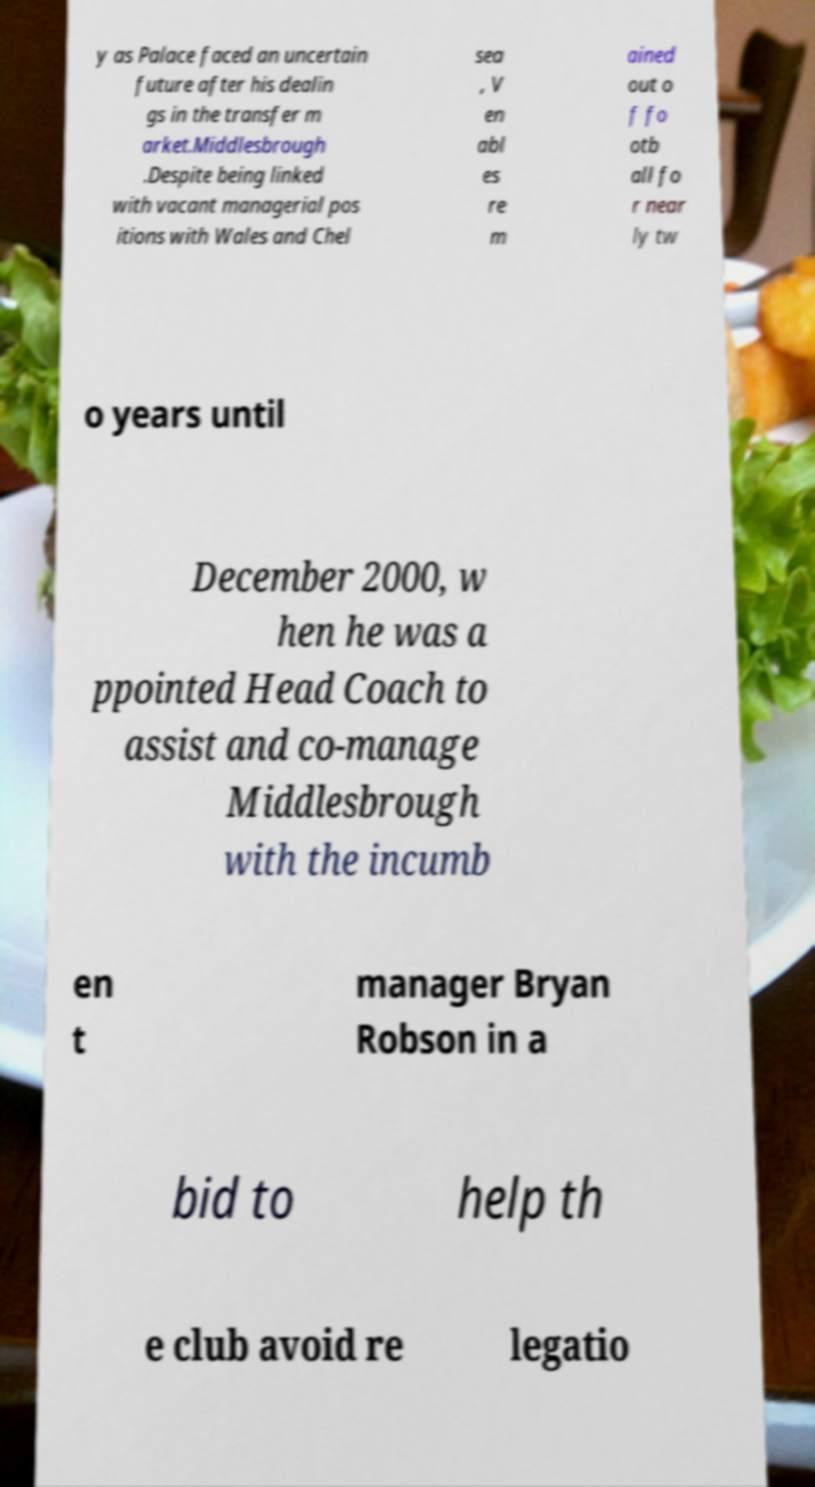Please read and relay the text visible in this image. What does it say? y as Palace faced an uncertain future after his dealin gs in the transfer m arket.Middlesbrough .Despite being linked with vacant managerial pos itions with Wales and Chel sea , V en abl es re m ained out o f fo otb all fo r near ly tw o years until December 2000, w hen he was a ppointed Head Coach to assist and co-manage Middlesbrough with the incumb en t manager Bryan Robson in a bid to help th e club avoid re legatio 